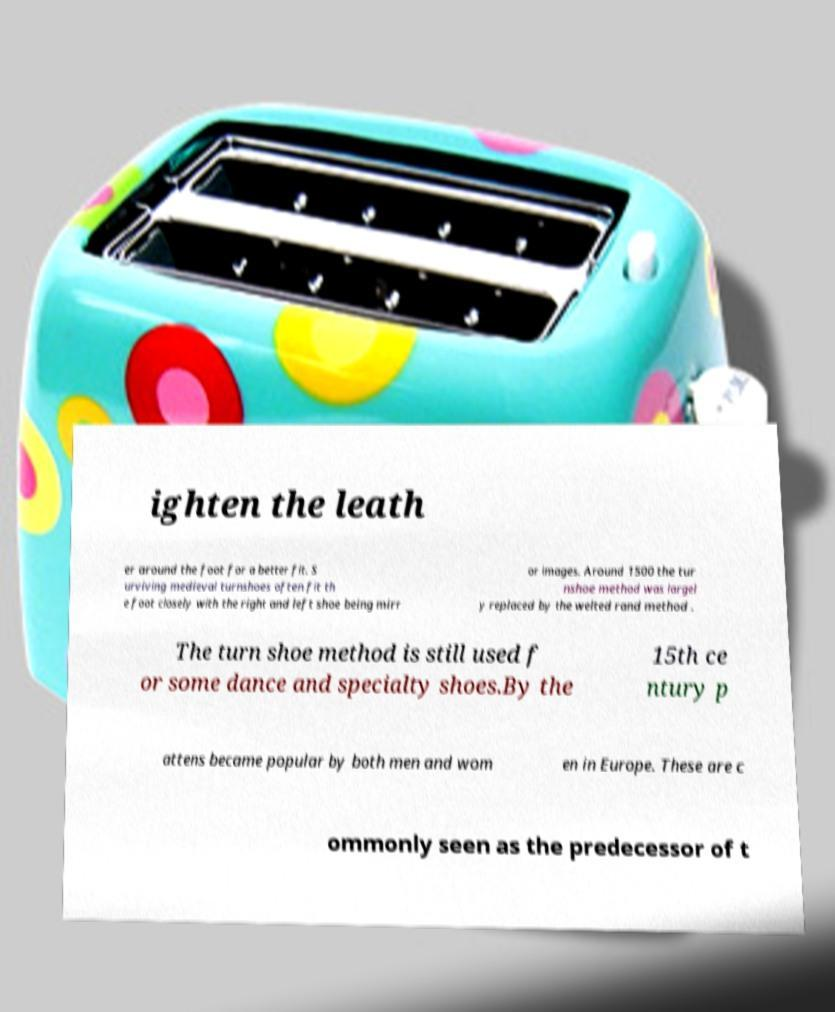I need the written content from this picture converted into text. Can you do that? ighten the leath er around the foot for a better fit. S urviving medieval turnshoes often fit th e foot closely with the right and left shoe being mirr or images. Around 1500 the tur nshoe method was largel y replaced by the welted rand method . The turn shoe method is still used f or some dance and specialty shoes.By the 15th ce ntury p attens became popular by both men and wom en in Europe. These are c ommonly seen as the predecessor of t 